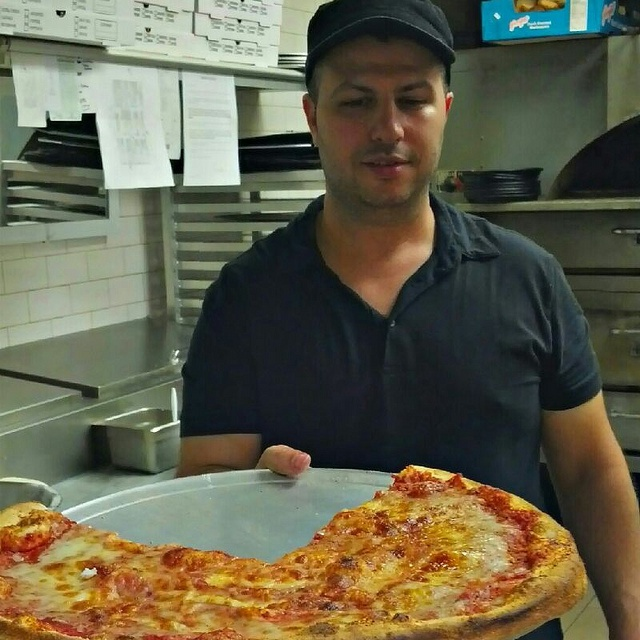Describe the objects in this image and their specific colors. I can see people in lightgray, black, maroon, and gray tones, pizza in lightgray, olive, and tan tones, oven in lightgray, black, and darkgreen tones, and spoon in lightgray, beige, darkgray, and gray tones in this image. 